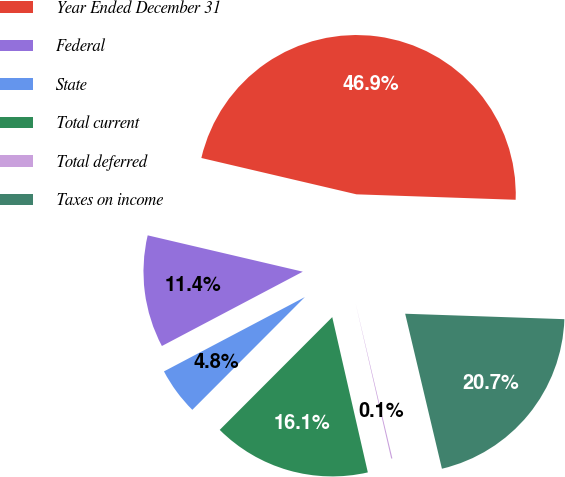Convert chart. <chart><loc_0><loc_0><loc_500><loc_500><pie_chart><fcel>Year Ended December 31<fcel>Federal<fcel>State<fcel>Total current<fcel>Total deferred<fcel>Taxes on income<nl><fcel>46.88%<fcel>11.39%<fcel>4.79%<fcel>16.07%<fcel>0.12%<fcel>20.75%<nl></chart> 